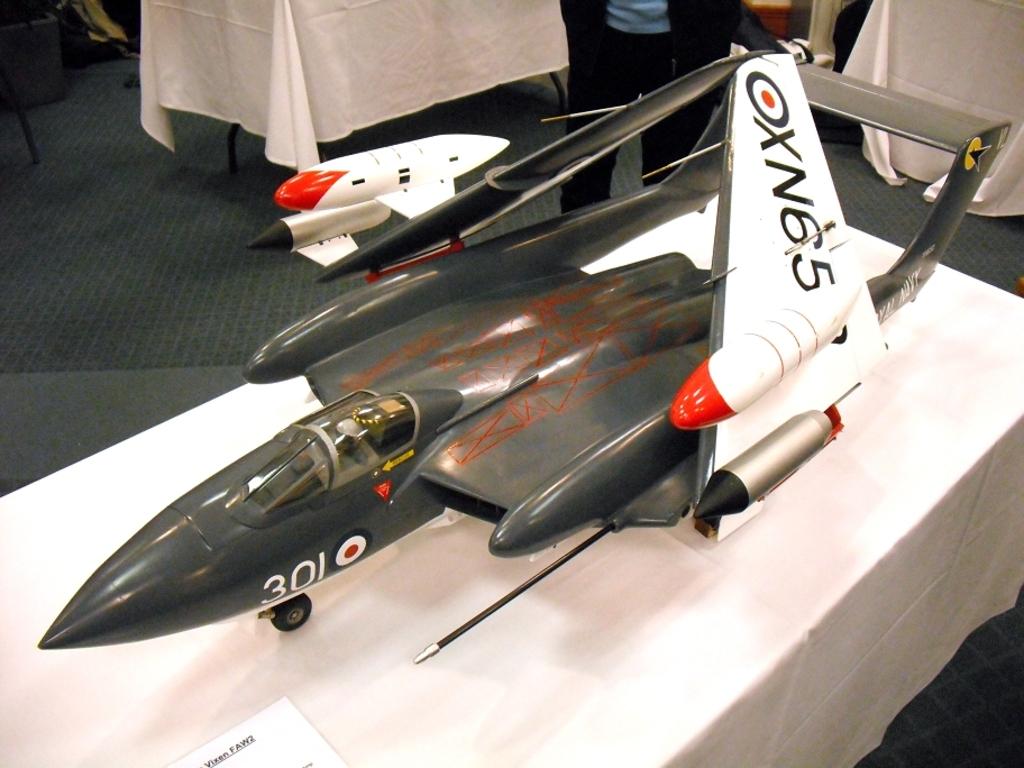What type of plane is this?
Offer a very short reply. Oxn65. What is the plane number?
Offer a terse response. 301. 